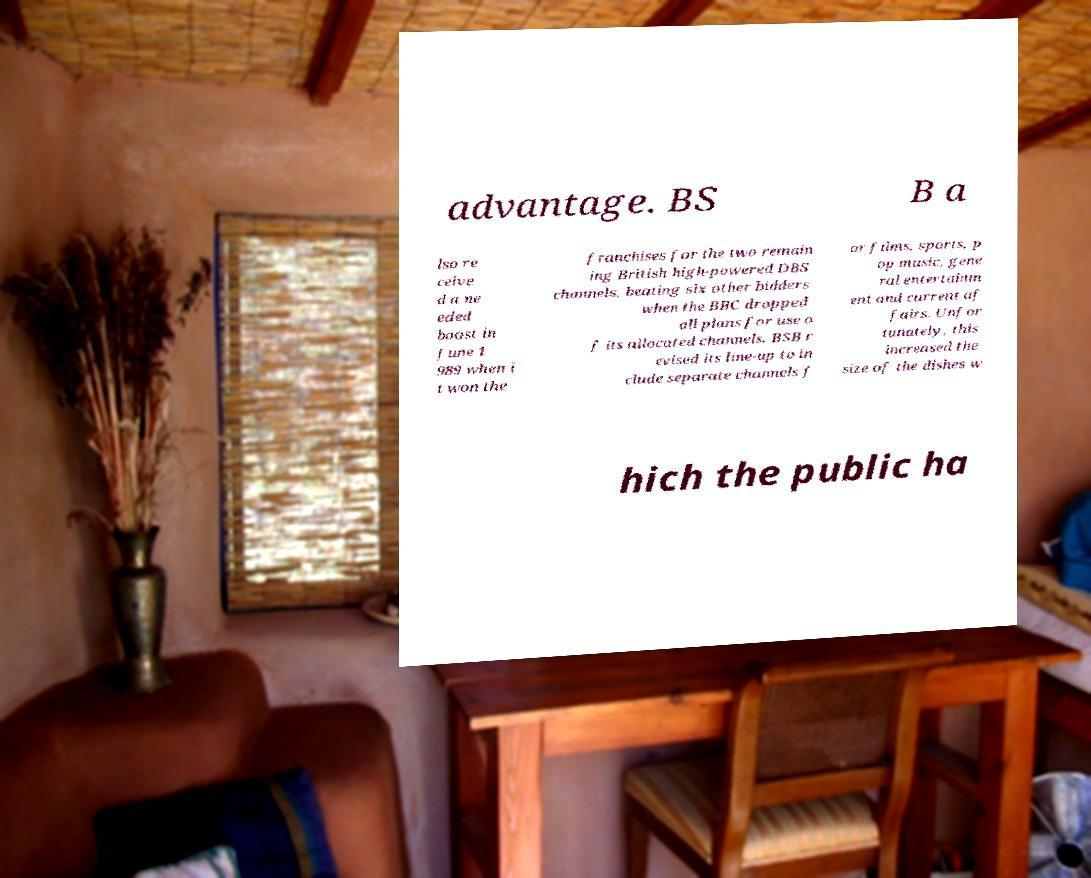For documentation purposes, I need the text within this image transcribed. Could you provide that? advantage. BS B a lso re ceive d a ne eded boost in June 1 989 when i t won the franchises for the two remain ing British high-powered DBS channels, beating six other bidders when the BBC dropped all plans for use o f its allocated channels. BSB r evised its line-up to in clude separate channels f or films, sports, p op music, gene ral entertainm ent and current af fairs. Unfor tunately, this increased the size of the dishes w hich the public ha 